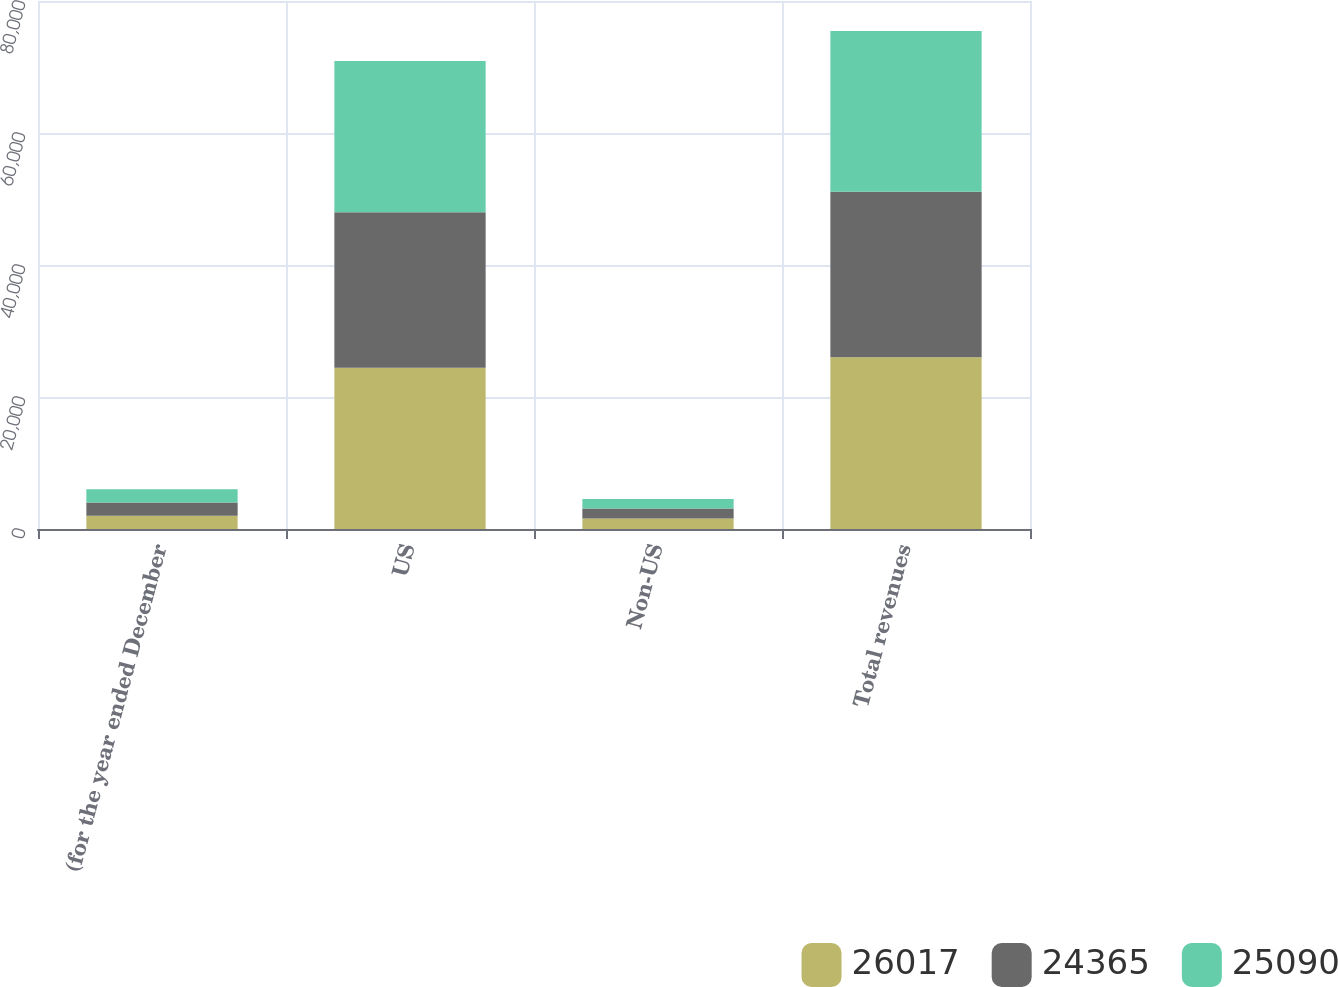Convert chart. <chart><loc_0><loc_0><loc_500><loc_500><stacked_bar_chart><ecel><fcel>(for the year ended December<fcel>US<fcel>Non-US<fcel>Total revenues<nl><fcel>26017<fcel>2007<fcel>24413<fcel>1604<fcel>26017<nl><fcel>24365<fcel>2006<fcel>23588<fcel>1502<fcel>25090<nl><fcel>25090<fcel>2005<fcel>22908<fcel>1457<fcel>24365<nl></chart> 